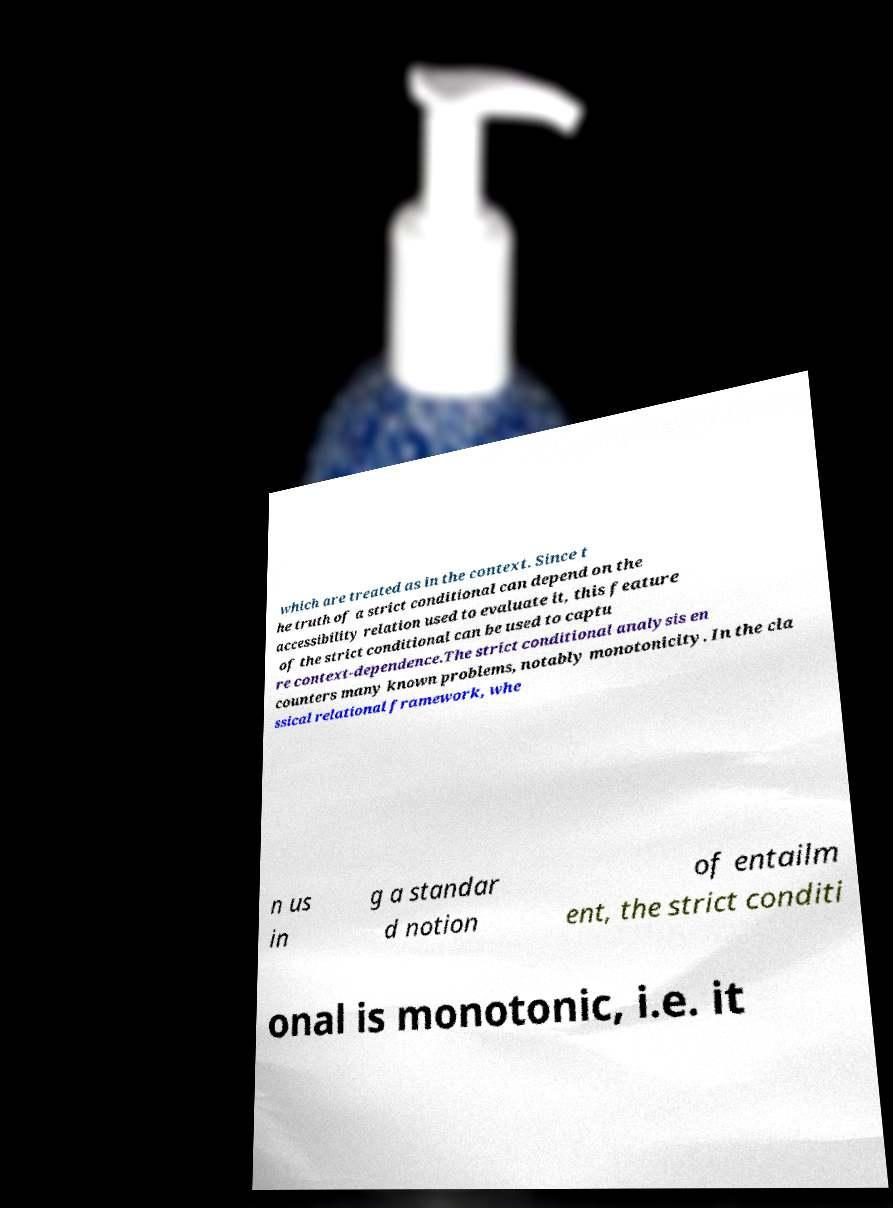Can you read and provide the text displayed in the image?This photo seems to have some interesting text. Can you extract and type it out for me? which are treated as in the context. Since t he truth of a strict conditional can depend on the accessibility relation used to evaluate it, this feature of the strict conditional can be used to captu re context-dependence.The strict conditional analysis en counters many known problems, notably monotonicity. In the cla ssical relational framework, whe n us in g a standar d notion of entailm ent, the strict conditi onal is monotonic, i.e. it 